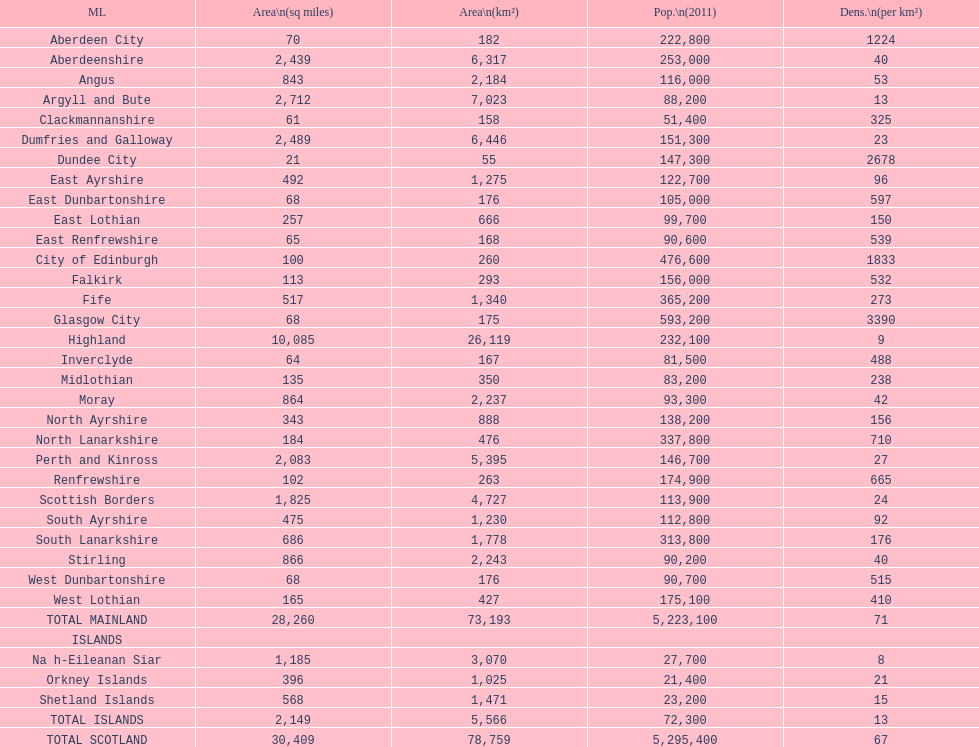Which is the only subdivision to have a greater area than argyll and bute? Highland. Would you be able to parse every entry in this table? {'header': ['ML', 'Area\\n(sq miles)', 'Area\\n(km²)', 'Pop.\\n(2011)', 'Dens.\\n(per km²)'], 'rows': [['Aberdeen City', '70', '182', '222,800', '1224'], ['Aberdeenshire', '2,439', '6,317', '253,000', '40'], ['Angus', '843', '2,184', '116,000', '53'], ['Argyll and Bute', '2,712', '7,023', '88,200', '13'], ['Clackmannanshire', '61', '158', '51,400', '325'], ['Dumfries and Galloway', '2,489', '6,446', '151,300', '23'], ['Dundee City', '21', '55', '147,300', '2678'], ['East Ayrshire', '492', '1,275', '122,700', '96'], ['East Dunbartonshire', '68', '176', '105,000', '597'], ['East Lothian', '257', '666', '99,700', '150'], ['East Renfrewshire', '65', '168', '90,600', '539'], ['City of Edinburgh', '100', '260', '476,600', '1833'], ['Falkirk', '113', '293', '156,000', '532'], ['Fife', '517', '1,340', '365,200', '273'], ['Glasgow City', '68', '175', '593,200', '3390'], ['Highland', '10,085', '26,119', '232,100', '9'], ['Inverclyde', '64', '167', '81,500', '488'], ['Midlothian', '135', '350', '83,200', '238'], ['Moray', '864', '2,237', '93,300', '42'], ['North Ayrshire', '343', '888', '138,200', '156'], ['North Lanarkshire', '184', '476', '337,800', '710'], ['Perth and Kinross', '2,083', '5,395', '146,700', '27'], ['Renfrewshire', '102', '263', '174,900', '665'], ['Scottish Borders', '1,825', '4,727', '113,900', '24'], ['South Ayrshire', '475', '1,230', '112,800', '92'], ['South Lanarkshire', '686', '1,778', '313,800', '176'], ['Stirling', '866', '2,243', '90,200', '40'], ['West Dunbartonshire', '68', '176', '90,700', '515'], ['West Lothian', '165', '427', '175,100', '410'], ['TOTAL MAINLAND', '28,260', '73,193', '5,223,100', '71'], ['ISLANDS', '', '', '', ''], ['Na h-Eileanan Siar', '1,185', '3,070', '27,700', '8'], ['Orkney Islands', '396', '1,025', '21,400', '21'], ['Shetland Islands', '568', '1,471', '23,200', '15'], ['TOTAL ISLANDS', '2,149', '5,566', '72,300', '13'], ['TOTAL SCOTLAND', '30,409', '78,759', '5,295,400', '67']]} 